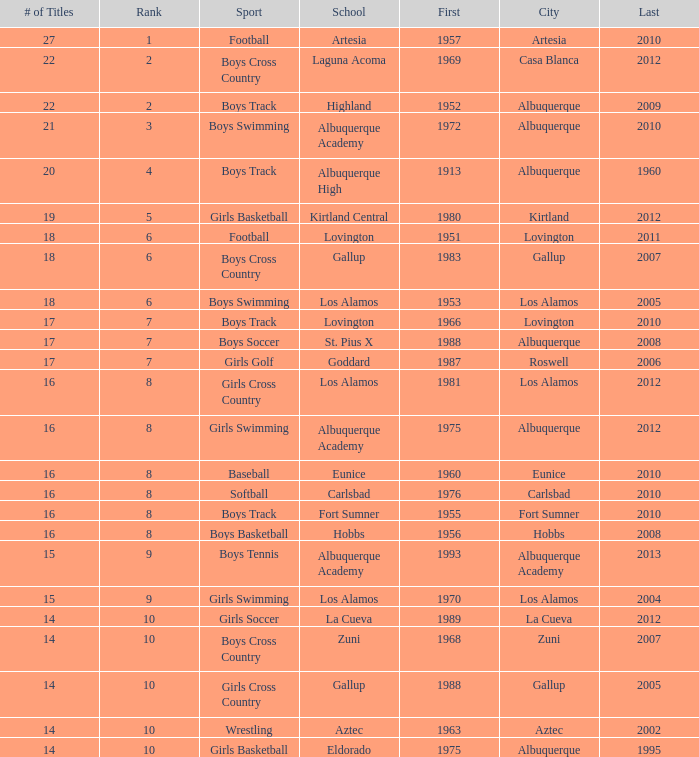What is the highest rank for the boys swimming team in Albuquerque? 3.0. 